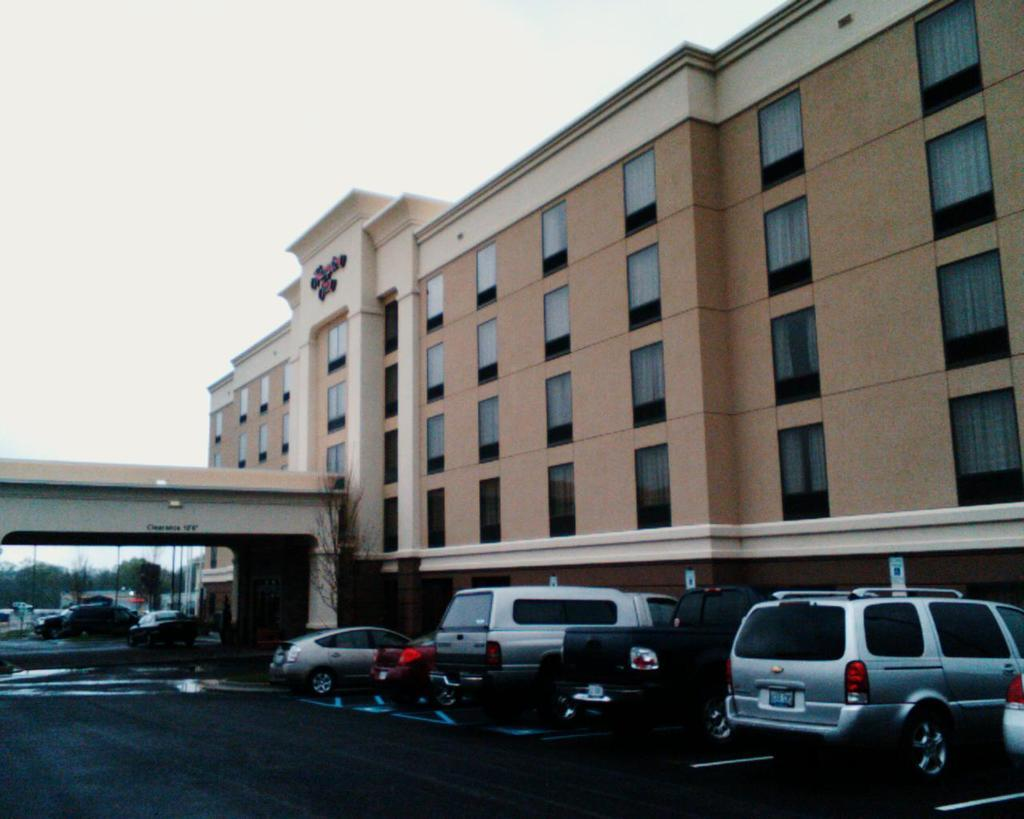What type of structure is visible in the image? There is a building in the image. What architectural features can be seen on the building? There are pillars in the image. What can be seen in the sky in the image? The sky is visible in the image. What are the vertical structures in the image? There are poles in the image. What type of vegetation is present in the image? There are trees in the image. What type of transportation is present on the road in the image? Motor vehicles are present on the road in the image. Can you hear the approval of the trees in the image? There is no indication of sound or approval in the image, as it is a static visual representation. 